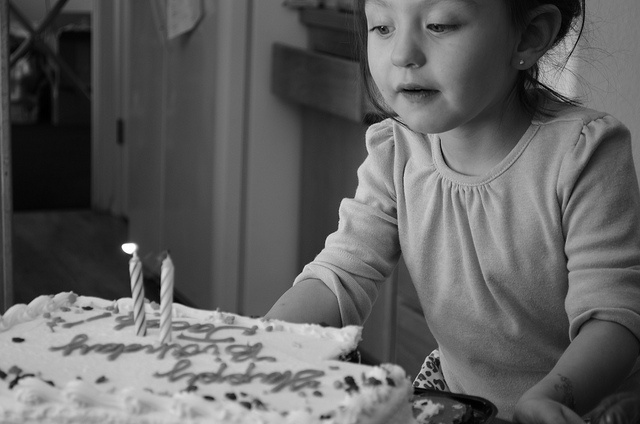Describe the objects in this image and their specific colors. I can see people in black, gray, darkgray, and lightgray tones and cake in black, darkgray, lightgray, and gray tones in this image. 